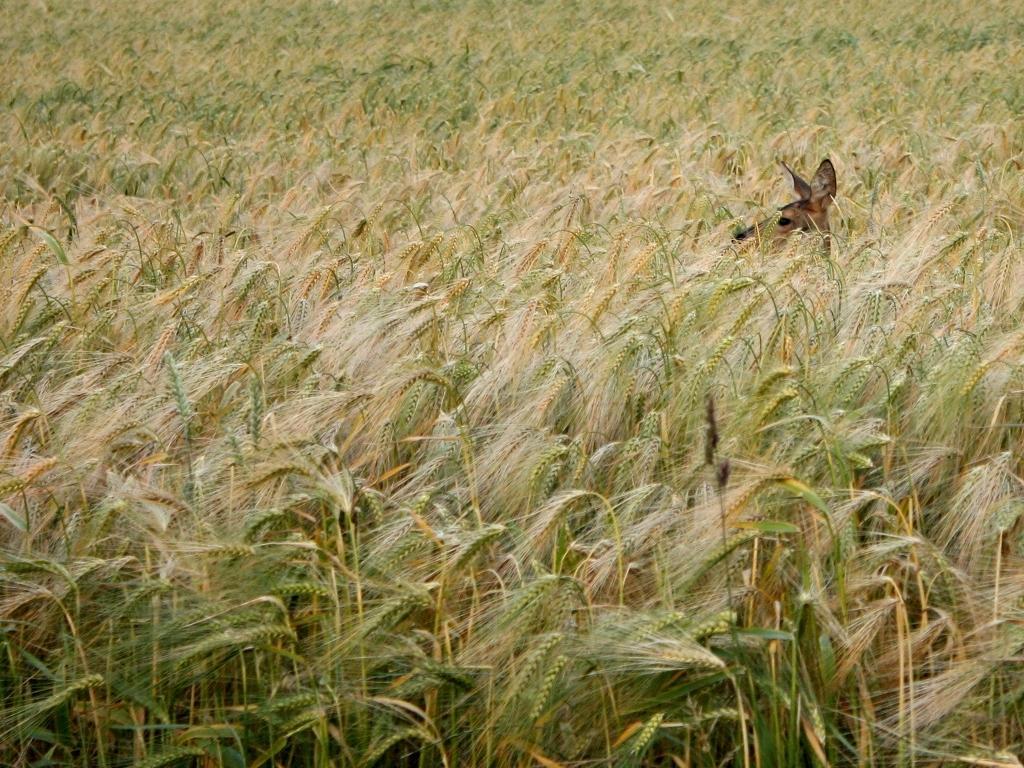Could you give a brief overview of what you see in this image? In this picture we can see an animal and plants. 